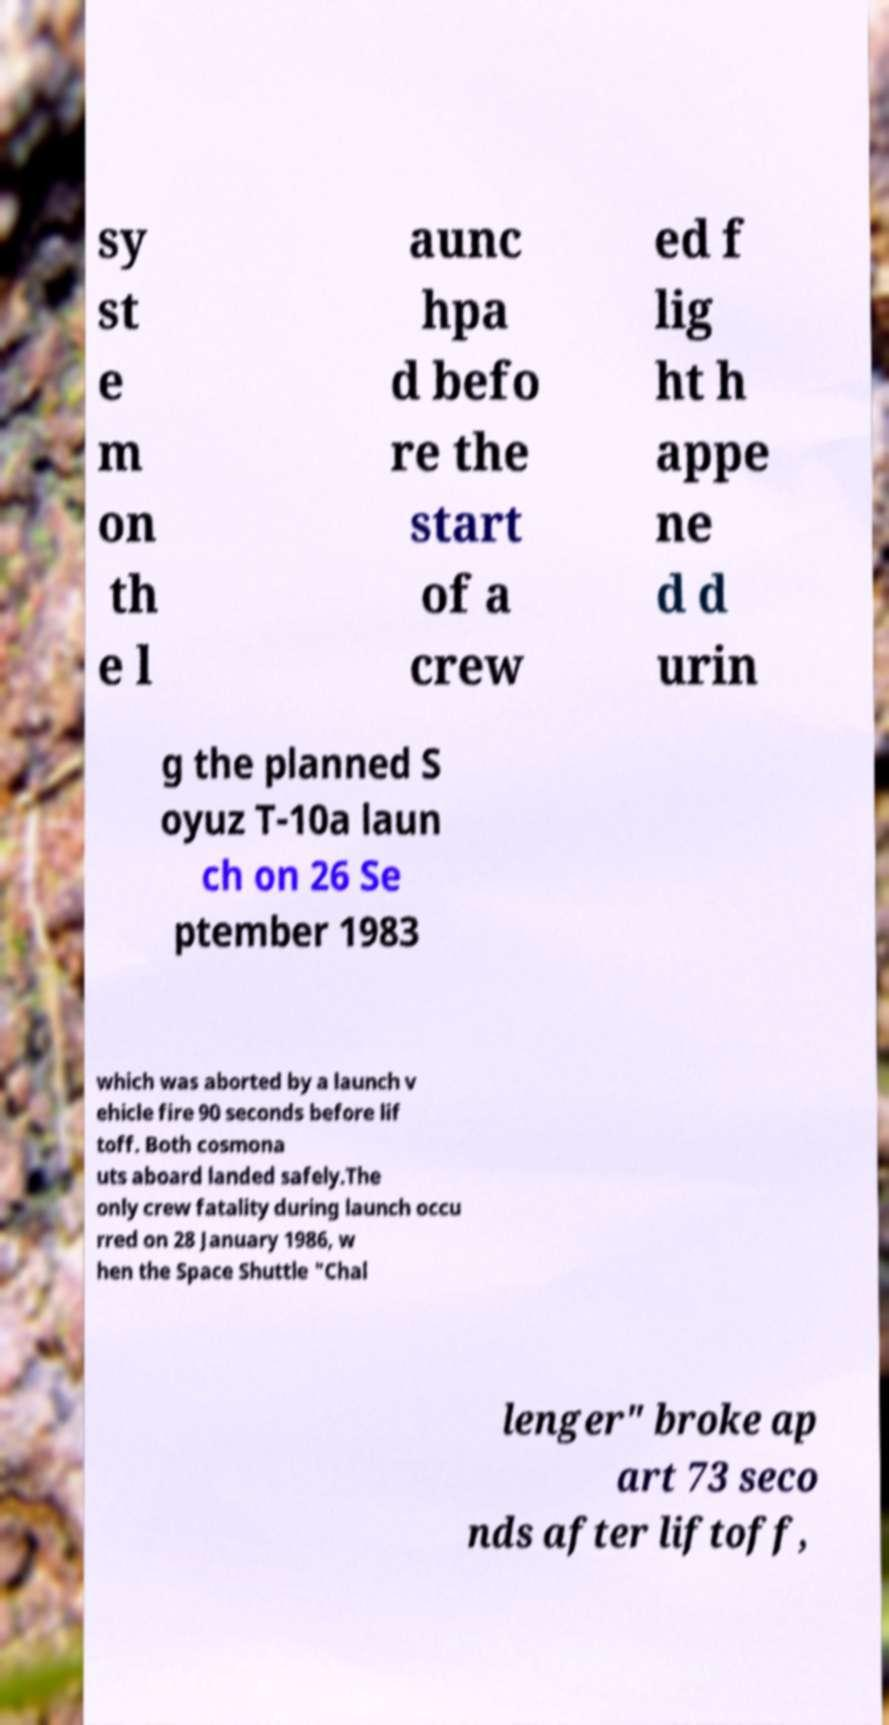For documentation purposes, I need the text within this image transcribed. Could you provide that? sy st e m on th e l aunc hpa d befo re the start of a crew ed f lig ht h appe ne d d urin g the planned S oyuz T-10a laun ch on 26 Se ptember 1983 which was aborted by a launch v ehicle fire 90 seconds before lif toff. Both cosmona uts aboard landed safely.The only crew fatality during launch occu rred on 28 January 1986, w hen the Space Shuttle "Chal lenger" broke ap art 73 seco nds after liftoff, 